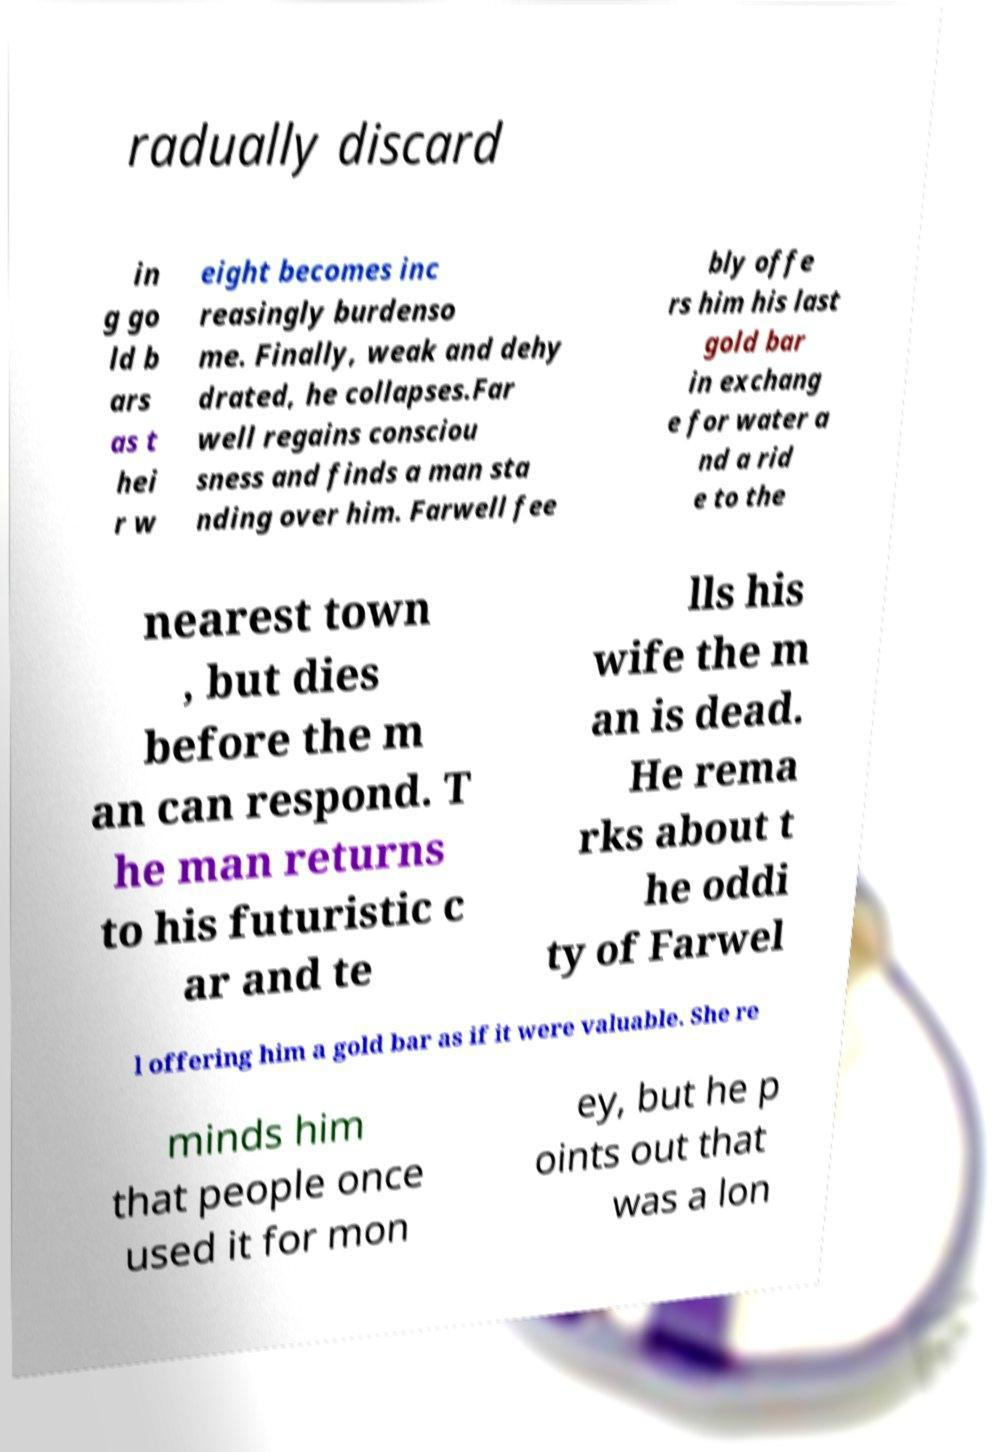Can you read and provide the text displayed in the image?This photo seems to have some interesting text. Can you extract and type it out for me? radually discard in g go ld b ars as t hei r w eight becomes inc reasingly burdenso me. Finally, weak and dehy drated, he collapses.Far well regains consciou sness and finds a man sta nding over him. Farwell fee bly offe rs him his last gold bar in exchang e for water a nd a rid e to the nearest town , but dies before the m an can respond. T he man returns to his futuristic c ar and te lls his wife the m an is dead. He rema rks about t he oddi ty of Farwel l offering him a gold bar as if it were valuable. She re minds him that people once used it for mon ey, but he p oints out that was a lon 